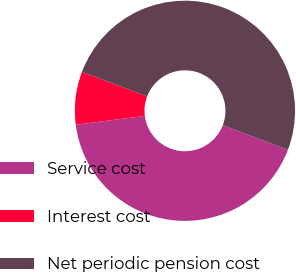<chart> <loc_0><loc_0><loc_500><loc_500><pie_chart><fcel>Service cost<fcel>Interest cost<fcel>Net periodic pension cost<nl><fcel>42.21%<fcel>7.79%<fcel>50.0%<nl></chart> 